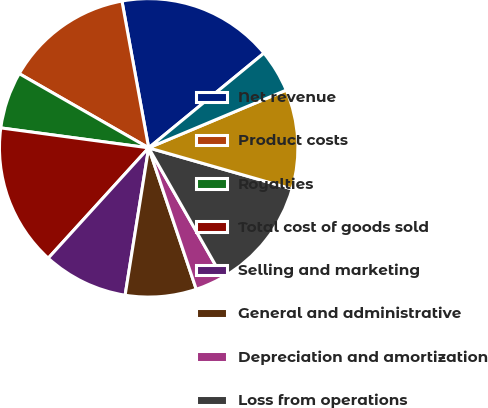Convert chart. <chart><loc_0><loc_0><loc_500><loc_500><pie_chart><fcel>Net revenue<fcel>Product costs<fcel>Royalties<fcel>Total cost of goods sold<fcel>Selling and marketing<fcel>General and administrative<fcel>Depreciation and amortization<fcel>Loss from operations<fcel>Loss before income taxes<fcel>Net Loss<nl><fcel>16.92%<fcel>13.85%<fcel>6.15%<fcel>15.38%<fcel>9.23%<fcel>7.69%<fcel>3.08%<fcel>12.31%<fcel>10.77%<fcel>4.62%<nl></chart> 